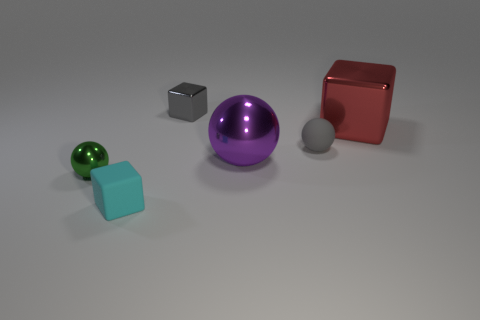Add 2 tiny blocks. How many objects exist? 8 Subtract all small balls. How many balls are left? 1 Subtract 2 blocks. How many blocks are left? 1 Add 2 tiny rubber objects. How many tiny rubber objects are left? 4 Add 3 matte cubes. How many matte cubes exist? 4 Subtract all red cubes. How many cubes are left? 2 Subtract 0 blue spheres. How many objects are left? 6 Subtract all brown cubes. Subtract all blue cylinders. How many cubes are left? 3 Subtract all blue blocks. How many purple balls are left? 1 Subtract all gray metallic things. Subtract all cyan cubes. How many objects are left? 4 